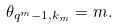<formula> <loc_0><loc_0><loc_500><loc_500>\theta _ { q ^ { m } - 1 , k _ { m } } = m .</formula> 